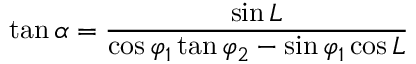<formula> <loc_0><loc_0><loc_500><loc_500>\tan \alpha = { \frac { \sin L } { \cos \varphi _ { 1 } \tan \varphi _ { 2 } - \sin \varphi _ { 1 } \cos L } }</formula> 